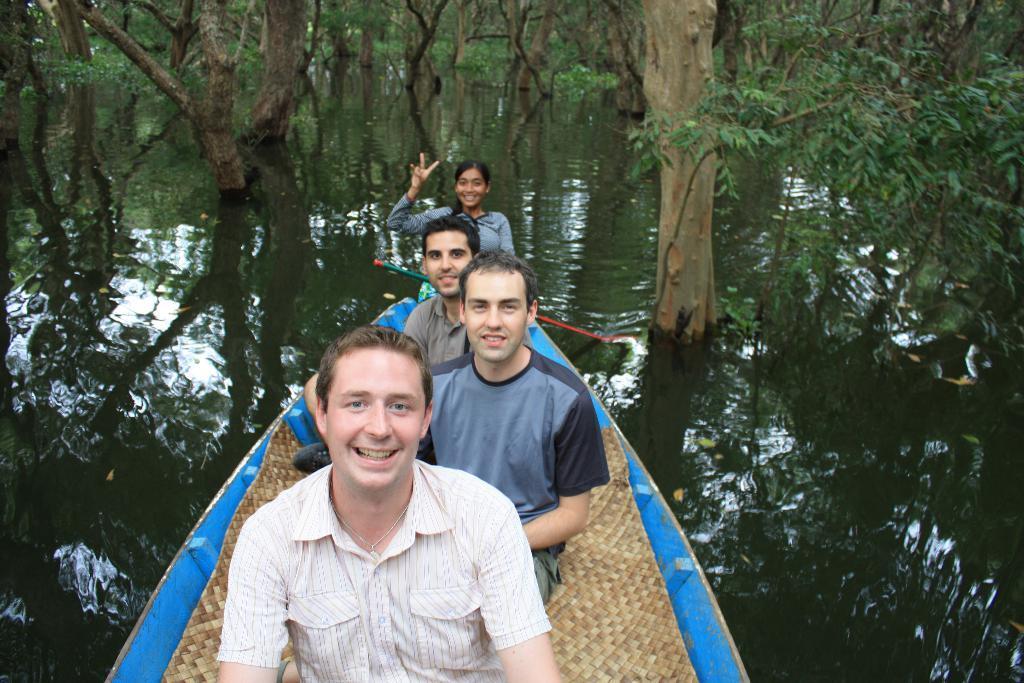Describe this image in one or two sentences. In this image we can see people are sitting in a boat. The boat is on the surface of water. There are trees at the top of the image. 